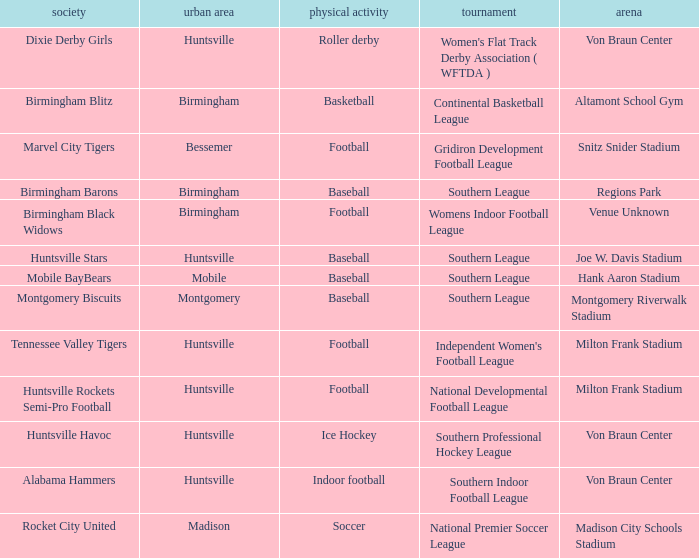Which city has a club called the Huntsville Stars? Huntsville. 